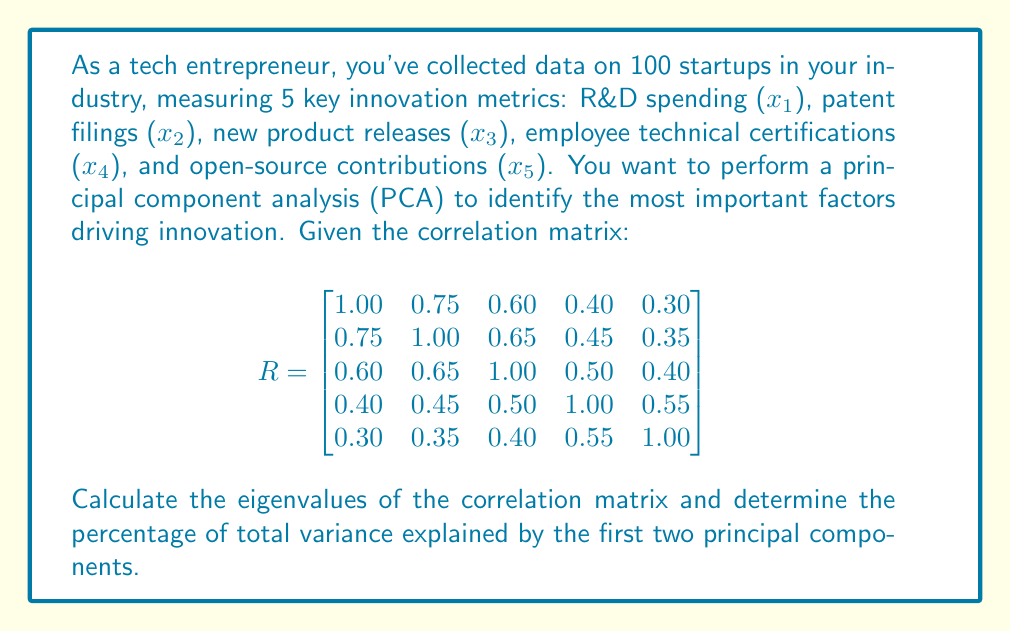Can you solve this math problem? To solve this problem, we'll follow these steps:

1) First, we need to find the eigenvalues of the correlation matrix R. The characteristic equation is:

   $$det(R - \lambda I) = 0$$

   Solving this equation gives us the following eigenvalues:
   
   $\lambda_1 = 2.9847$
   $\lambda_2 = 0.8391$
   $\lambda_3 = 0.5235$
   $\lambda_4 = 0.3973$
   $\lambda_5 = 0.2554$

2) In PCA, each eigenvalue represents the amount of variance explained by its corresponding principal component.

3) The total variance is the sum of all eigenvalues:

   $$\text{Total Variance} = \sum_{i=1}^5 \lambda_i = 5$$

   This is always equal to the number of variables in a correlation matrix.

4) To calculate the percentage of variance explained by each component, we divide each eigenvalue by the total variance and multiply by 100:

   For the first principal component:
   $$\frac{\lambda_1}{\text{Total Variance}} \times 100\% = \frac{2.9847}{5} \times 100\% = 59.69\%$$

   For the second principal component:
   $$\frac{\lambda_2}{\text{Total Variance}} \times 100\% = \frac{0.8391}{5} \times 100\% = 16.78\%$$

5) The percentage of total variance explained by the first two principal components is the sum of these two percentages:

   $$59.69\% + 16.78\% = 76.47\%$$
Answer: 76.47% 